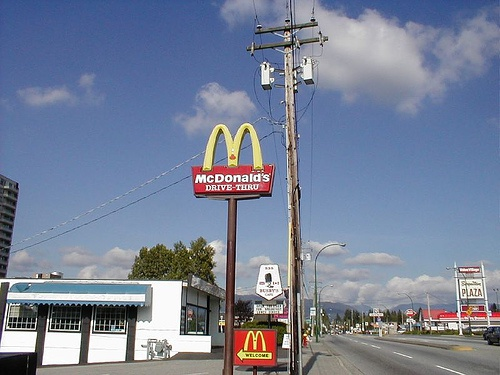Describe the objects in this image and their specific colors. I can see a car in blue, black, gray, and darkgray tones in this image. 